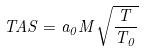<formula> <loc_0><loc_0><loc_500><loc_500>T A S = a _ { 0 } M \sqrt { \frac { T } { T _ { 0 } } }</formula> 